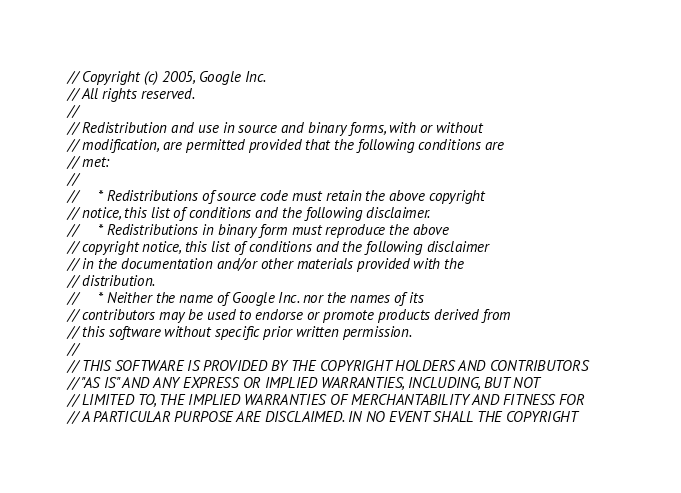Convert code to text. <code><loc_0><loc_0><loc_500><loc_500><_C_>// Copyright (c) 2005, Google Inc.
// All rights reserved.
//
// Redistribution and use in source and binary forms, with or without
// modification, are permitted provided that the following conditions are
// met:
//
//     * Redistributions of source code must retain the above copyright
// notice, this list of conditions and the following disclaimer.
//     * Redistributions in binary form must reproduce the above
// copyright notice, this list of conditions and the following disclaimer
// in the documentation and/or other materials provided with the
// distribution.
//     * Neither the name of Google Inc. nor the names of its
// contributors may be used to endorse or promote products derived from
// this software without specific prior written permission.
//
// THIS SOFTWARE IS PROVIDED BY THE COPYRIGHT HOLDERS AND CONTRIBUTORS
// "AS IS" AND ANY EXPRESS OR IMPLIED WARRANTIES, INCLUDING, BUT NOT
// LIMITED TO, THE IMPLIED WARRANTIES OF MERCHANTABILITY AND FITNESS FOR
// A PARTICULAR PURPOSE ARE DISCLAIMED. IN NO EVENT SHALL THE COPYRIGHT</code> 